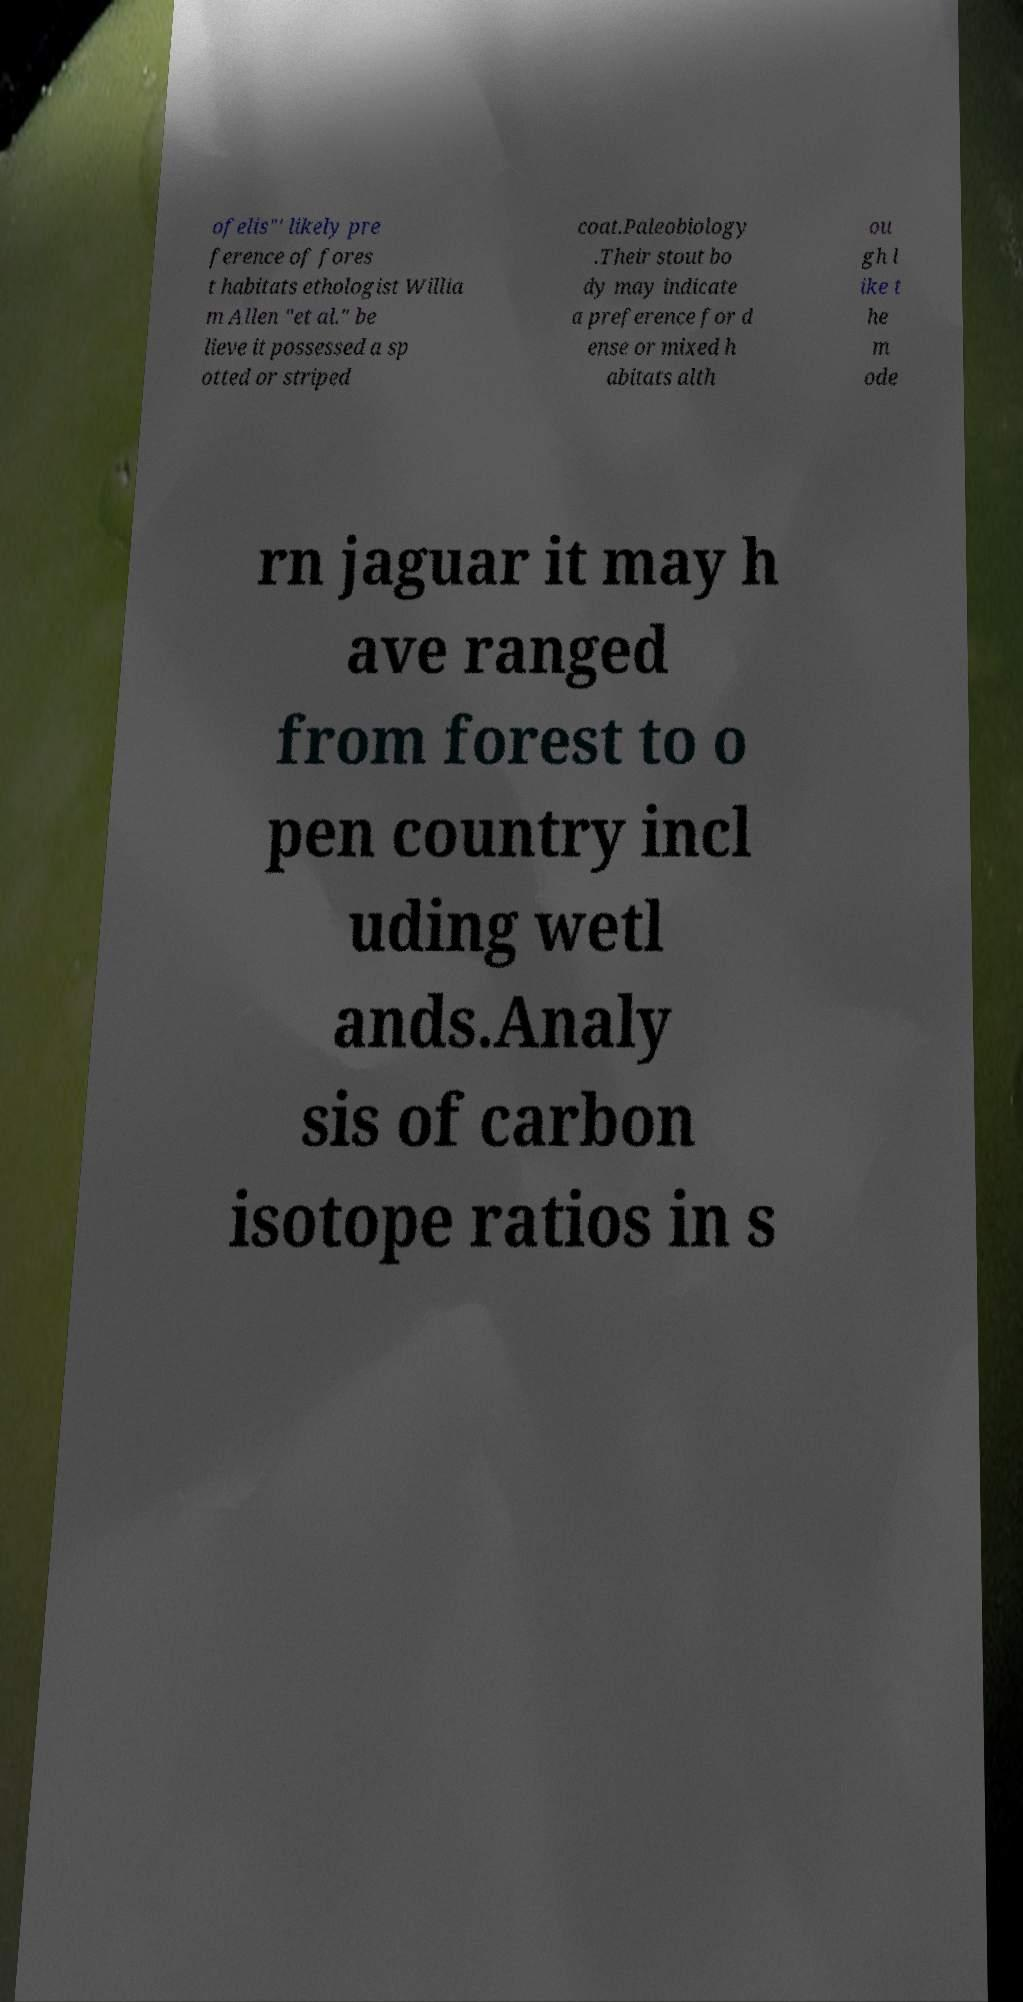Please identify and transcribe the text found in this image. ofelis"' likely pre ference of fores t habitats ethologist Willia m Allen "et al." be lieve it possessed a sp otted or striped coat.Paleobiology .Their stout bo dy may indicate a preference for d ense or mixed h abitats alth ou gh l ike t he m ode rn jaguar it may h ave ranged from forest to o pen country incl uding wetl ands.Analy sis of carbon isotope ratios in s 